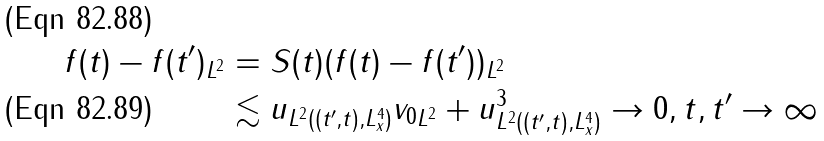Convert formula to latex. <formula><loc_0><loc_0><loc_500><loc_500>\| f ( t ) - f ( t ^ { \prime } ) \| _ { L ^ { 2 } } & = \| S ( t ) ( f ( t ) - f ( t ^ { \prime } ) ) \| _ { L ^ { 2 } } \\ & \lesssim \| u \| _ { L ^ { 2 } ( ( t ^ { \prime } , t ) , L ^ { 4 } _ { x } ) } \| v _ { 0 } \| _ { L ^ { 2 } } + \| u \| _ { L ^ { 2 } ( ( t ^ { \prime } , t ) , L ^ { 4 } _ { x } ) } ^ { 3 } \to 0 , t , t ^ { \prime } \to \infty</formula> 